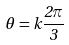<formula> <loc_0><loc_0><loc_500><loc_500>\theta = k \frac { 2 \pi } { 3 }</formula> 